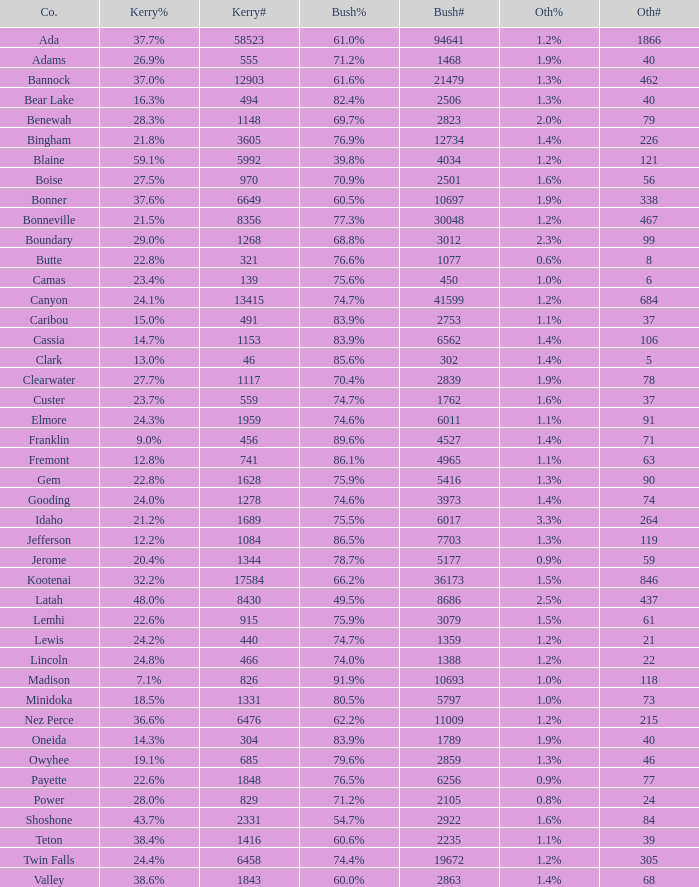What percentage of the votes were for others in the county where 462 people voted that way? 1.3%. 